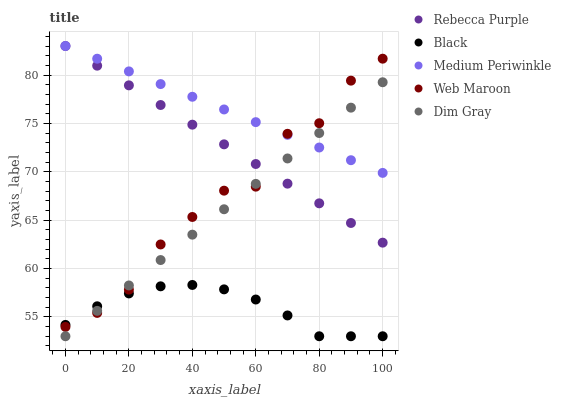Does Black have the minimum area under the curve?
Answer yes or no. Yes. Does Medium Periwinkle have the maximum area under the curve?
Answer yes or no. Yes. Does Dim Gray have the minimum area under the curve?
Answer yes or no. No. Does Dim Gray have the maximum area under the curve?
Answer yes or no. No. Is Rebecca Purple the smoothest?
Answer yes or no. Yes. Is Web Maroon the roughest?
Answer yes or no. Yes. Is Dim Gray the smoothest?
Answer yes or no. No. Is Dim Gray the roughest?
Answer yes or no. No. Does Dim Gray have the lowest value?
Answer yes or no. Yes. Does Rebecca Purple have the lowest value?
Answer yes or no. No. Does Rebecca Purple have the highest value?
Answer yes or no. Yes. Does Dim Gray have the highest value?
Answer yes or no. No. Is Black less than Medium Periwinkle?
Answer yes or no. Yes. Is Rebecca Purple greater than Black?
Answer yes or no. Yes. Does Dim Gray intersect Medium Periwinkle?
Answer yes or no. Yes. Is Dim Gray less than Medium Periwinkle?
Answer yes or no. No. Is Dim Gray greater than Medium Periwinkle?
Answer yes or no. No. Does Black intersect Medium Periwinkle?
Answer yes or no. No. 